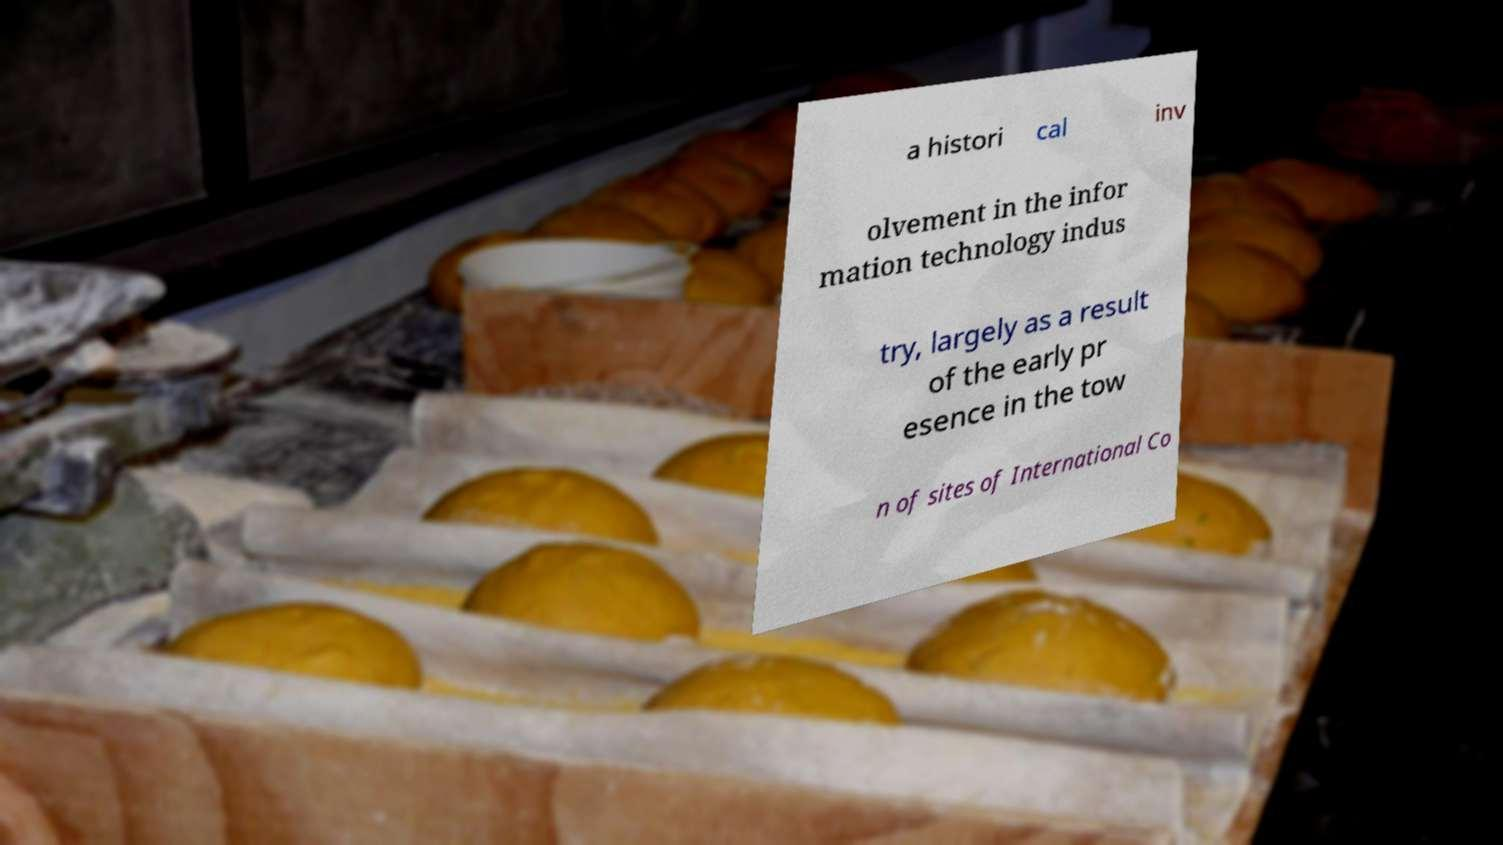Could you extract and type out the text from this image? a histori cal inv olvement in the infor mation technology indus try, largely as a result of the early pr esence in the tow n of sites of International Co 